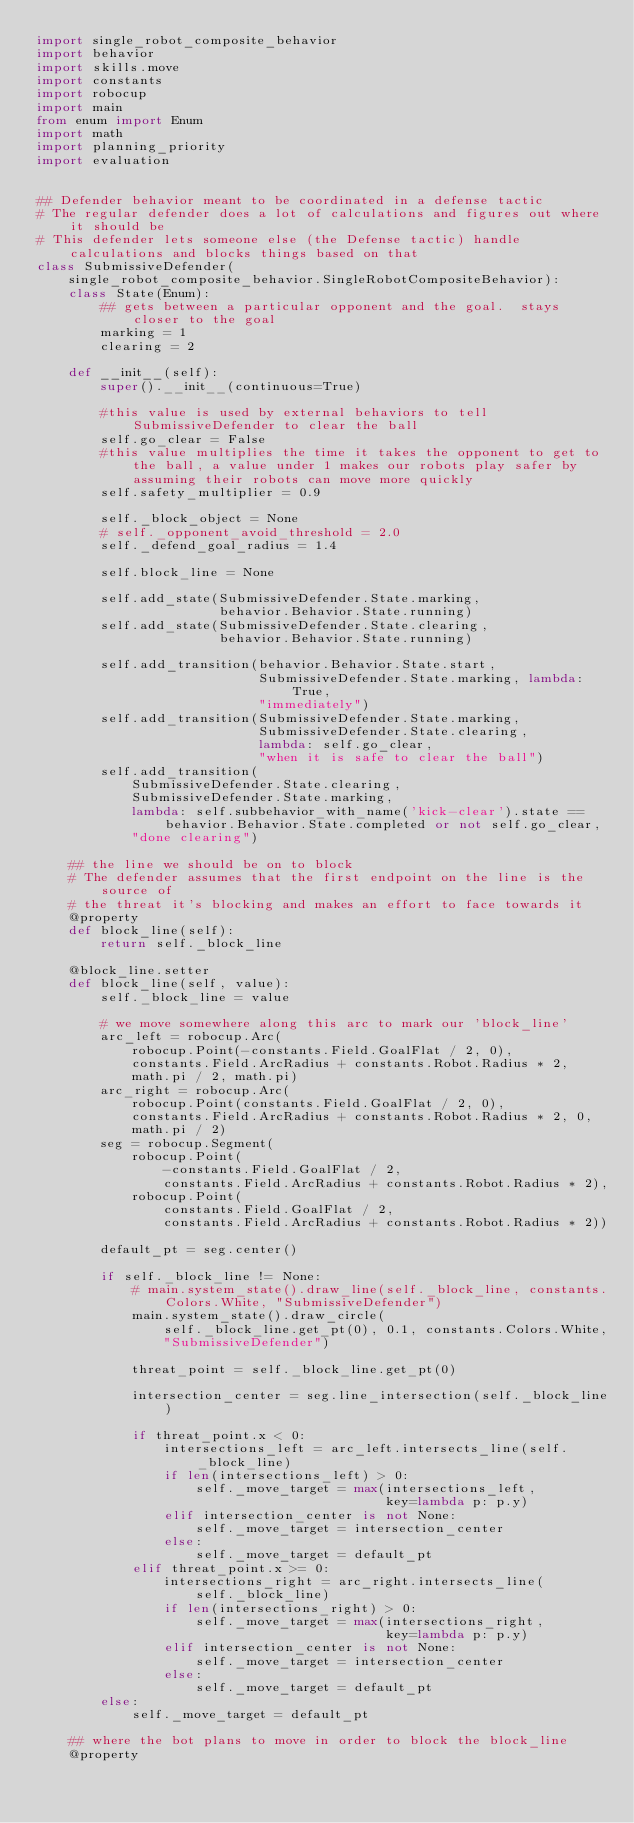Convert code to text. <code><loc_0><loc_0><loc_500><loc_500><_Python_>import single_robot_composite_behavior
import behavior
import skills.move
import constants
import robocup
import main
from enum import Enum
import math
import planning_priority
import evaluation


## Defender behavior meant to be coordinated in a defense tactic
# The regular defender does a lot of calculations and figures out where it should be
# This defender lets someone else (the Defense tactic) handle calculations and blocks things based on that
class SubmissiveDefender(
    single_robot_composite_behavior.SingleRobotCompositeBehavior):
    class State(Enum):
        ## gets between a particular opponent and the goal.  stays closer to the goal
        marking = 1
        clearing = 2

    def __init__(self):
        super().__init__(continuous=True)

        #this value is used by external behaviors to tell SubmissiveDefender to clear the ball
        self.go_clear = False
        #this value multiplies the time it takes the opponent to get to the ball, a value under 1 makes our robots play safer by assuming their robots can move more quickly
        self.safety_multiplier = 0.9

        self._block_object = None
        # self._opponent_avoid_threshold = 2.0
        self._defend_goal_radius = 1.4

        self.block_line = None

        self.add_state(SubmissiveDefender.State.marking,
                       behavior.Behavior.State.running)
        self.add_state(SubmissiveDefender.State.clearing,
                       behavior.Behavior.State.running)

        self.add_transition(behavior.Behavior.State.start,
                            SubmissiveDefender.State.marking, lambda: True,
                            "immediately")
        self.add_transition(SubmissiveDefender.State.marking,
                            SubmissiveDefender.State.clearing,
                            lambda: self.go_clear,
                            "when it is safe to clear the ball")
        self.add_transition(
            SubmissiveDefender.State.clearing,
            SubmissiveDefender.State.marking,
            lambda: self.subbehavior_with_name('kick-clear').state == behavior.Behavior.State.completed or not self.go_clear,
            "done clearing")

    ## the line we should be on to block
    # The defender assumes that the first endpoint on the line is the source of
    # the threat it's blocking and makes an effort to face towards it
    @property
    def block_line(self):
        return self._block_line

    @block_line.setter
    def block_line(self, value):
        self._block_line = value

        # we move somewhere along this arc to mark our 'block_line'
        arc_left = robocup.Arc(
            robocup.Point(-constants.Field.GoalFlat / 2, 0),
            constants.Field.ArcRadius + constants.Robot.Radius * 2,
            math.pi / 2, math.pi)
        arc_right = robocup.Arc(
            robocup.Point(constants.Field.GoalFlat / 2, 0),
            constants.Field.ArcRadius + constants.Robot.Radius * 2, 0,
            math.pi / 2)
        seg = robocup.Segment(
            robocup.Point(
                -constants.Field.GoalFlat / 2,
                constants.Field.ArcRadius + constants.Robot.Radius * 2),
            robocup.Point(
                constants.Field.GoalFlat / 2,
                constants.Field.ArcRadius + constants.Robot.Radius * 2))

        default_pt = seg.center()

        if self._block_line != None:
            # main.system_state().draw_line(self._block_line, constants.Colors.White, "SubmissiveDefender")
            main.system_state().draw_circle(
                self._block_line.get_pt(0), 0.1, constants.Colors.White,
                "SubmissiveDefender")

            threat_point = self._block_line.get_pt(0)

            intersection_center = seg.line_intersection(self._block_line)

            if threat_point.x < 0:
                intersections_left = arc_left.intersects_line(self._block_line)
                if len(intersections_left) > 0:
                    self._move_target = max(intersections_left,
                                            key=lambda p: p.y)
                elif intersection_center is not None:
                    self._move_target = intersection_center
                else:
                    self._move_target = default_pt
            elif threat_point.x >= 0:
                intersections_right = arc_right.intersects_line(
                    self._block_line)
                if len(intersections_right) > 0:
                    self._move_target = max(intersections_right,
                                            key=lambda p: p.y)
                elif intersection_center is not None:
                    self._move_target = intersection_center
                else:
                    self._move_target = default_pt
        else:
            self._move_target = default_pt

    ## where the bot plans to move in order to block the block_line
    @property</code> 